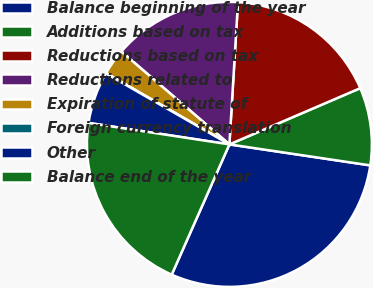Convert chart to OTSL. <chart><loc_0><loc_0><loc_500><loc_500><pie_chart><fcel>Balance beginning of the year<fcel>Additions based on tax<fcel>Reductions based on tax<fcel>Reductions related to<fcel>Expiration of statute of<fcel>Foreign currency translation<fcel>Other<fcel>Balance end of the year<nl><fcel>29.28%<fcel>8.81%<fcel>17.58%<fcel>14.66%<fcel>2.96%<fcel>0.04%<fcel>5.89%<fcel>20.77%<nl></chart> 